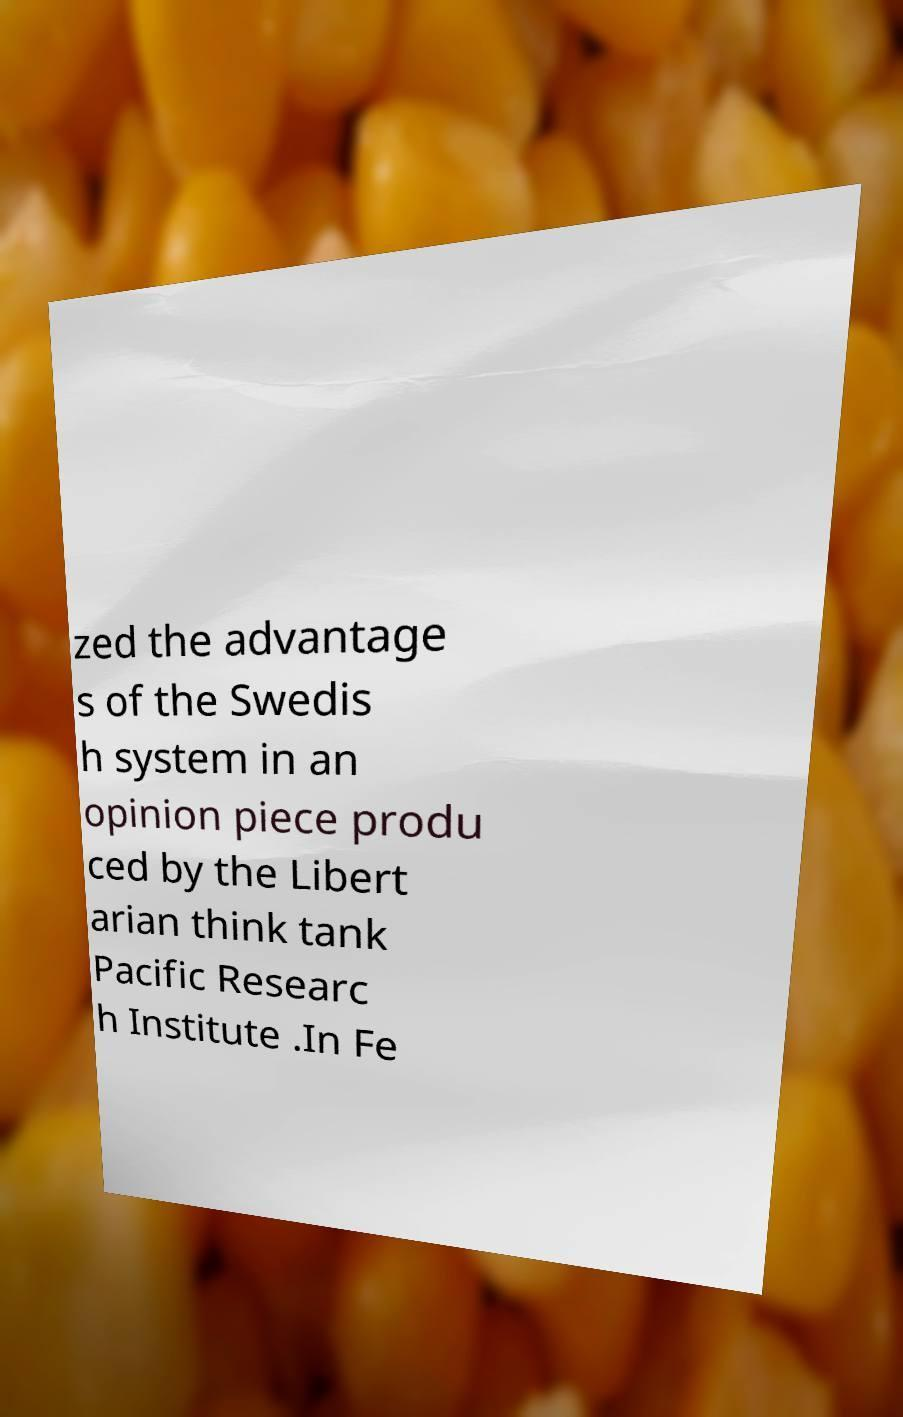Can you read and provide the text displayed in the image?This photo seems to have some interesting text. Can you extract and type it out for me? zed the advantage s of the Swedis h system in an opinion piece produ ced by the Libert arian think tank Pacific Researc h Institute .In Fe 